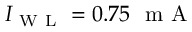Convert formula to latex. <formula><loc_0><loc_0><loc_500><loc_500>I _ { W L } = 0 . 7 5 m A</formula> 